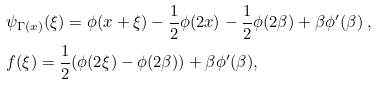<formula> <loc_0><loc_0><loc_500><loc_500>& \psi _ { \Gamma ( x ) } ( \xi ) = \phi ( x + \xi ) - \frac { 1 } { 2 } \phi ( 2 x ) - \frac { 1 } { 2 } \phi ( 2 \beta ) + \beta \phi ^ { \prime } ( \beta ) \ , \\ & f ( \xi ) = \frac { 1 } { 2 } ( \phi ( 2 \xi ) - \phi ( 2 \beta ) ) + \beta \phi ^ { \prime } ( \beta ) ,</formula> 